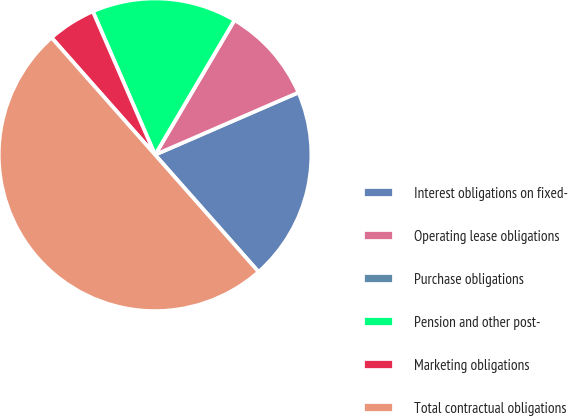<chart> <loc_0><loc_0><loc_500><loc_500><pie_chart><fcel>Interest obligations on fixed-<fcel>Operating lease obligations<fcel>Purchase obligations<fcel>Pension and other post-<fcel>Marketing obligations<fcel>Total contractual obligations<nl><fcel>20.0%<fcel>10.0%<fcel>0.0%<fcel>15.0%<fcel>5.0%<fcel>50.0%<nl></chart> 